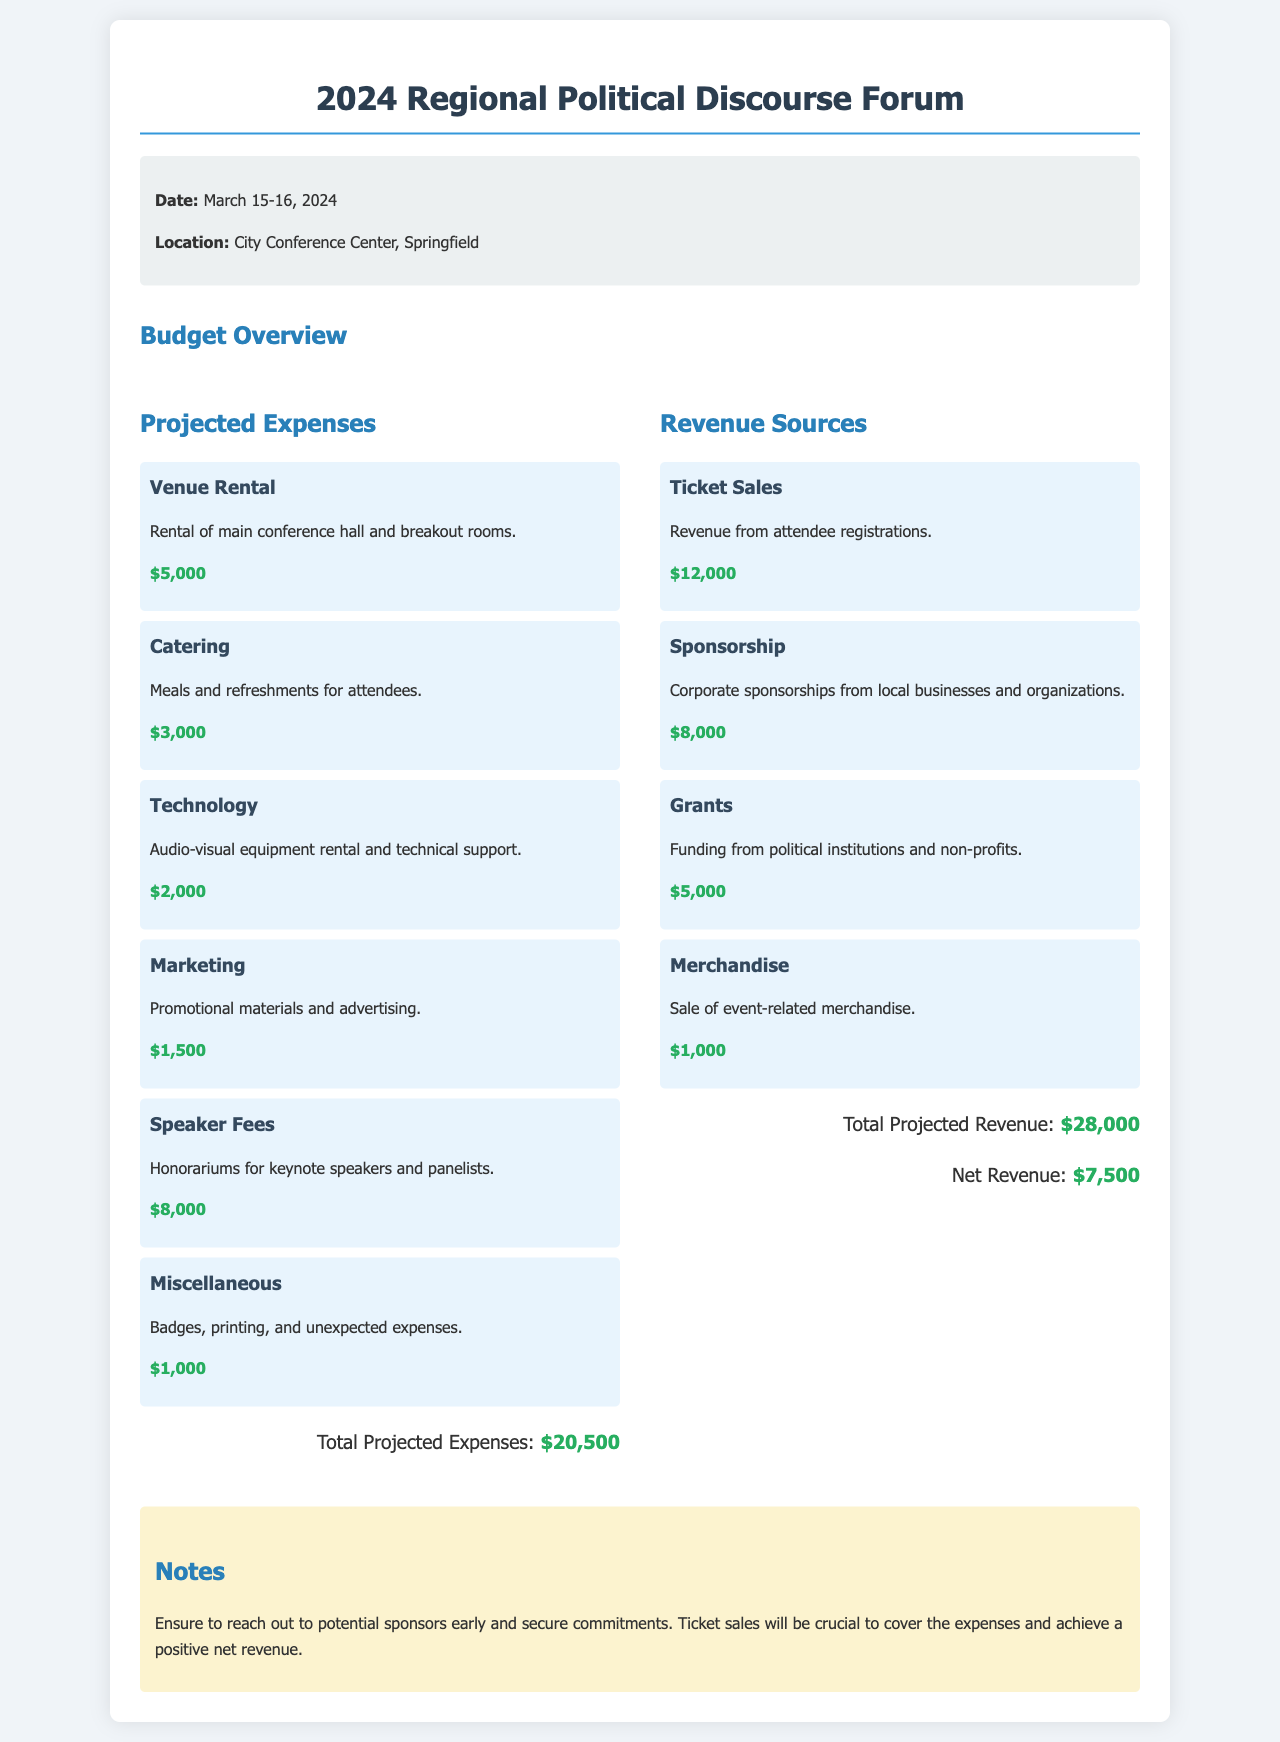What are the dates of the forum? The dates of the forum are listed in the event information section of the document.
Answer: March 15-16, 2024 What is the location of the forum? The location of the forum is mentioned in the event information section of the document.
Answer: City Conference Center, Springfield What is the total projected expenses? The total projected expenses are calculated based on the sum of all expense items listed in the document.
Answer: $20,500 What is the total projected revenue? The total projected revenue is calculated from the sum of all revenue sources mentioned in the document.
Answer: $28,000 What is the amount for speaker fees? The amount listed under speaker fees provides specific information about one of the expense items.
Answer: $8,000 What is the net revenue? The net revenue is determined by subtracting total expenses from total revenue, as indicated in the document.
Answer: $7,500 How much is allocated for technology? The specific expense for technology is stated in the budget overview section.
Answer: $2,000 What percentage of total revenue comes from ticket sales? To find the percentage, divide the ticket sales amount by total revenue and multiply by 100, as indicated in the revenue section.
Answer: 42.86% What are the miscellaneous expenses? The section detailing various expenses provides straightforward details regarding miscellaneous costs.
Answer: $1,000 What should be prioritized according to the notes? The notes section gives guidance on actions to take for the event's financial success.
Answer: Reach out to potential sponsors early 